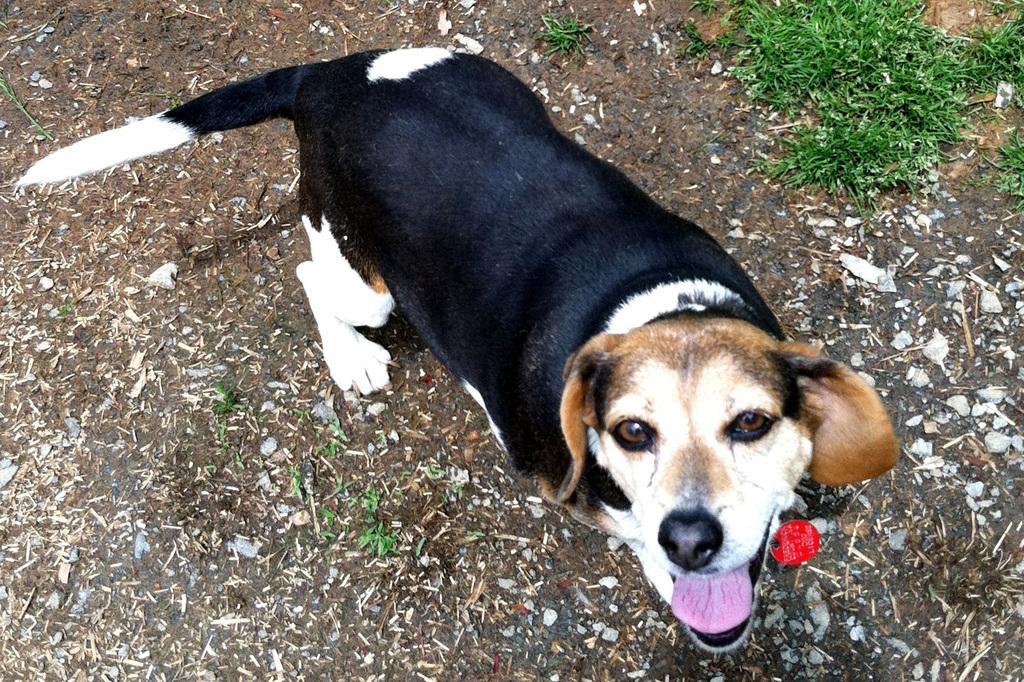What type of animal is in the picture? There is a dog in the picture. Can you describe the colors of the dog? The dog has brown, black, and white colors. What type of stick is the dog using to perform division in the image? There is no stick or division activity present in the image; it features a dog with brown, black, and white colors. 